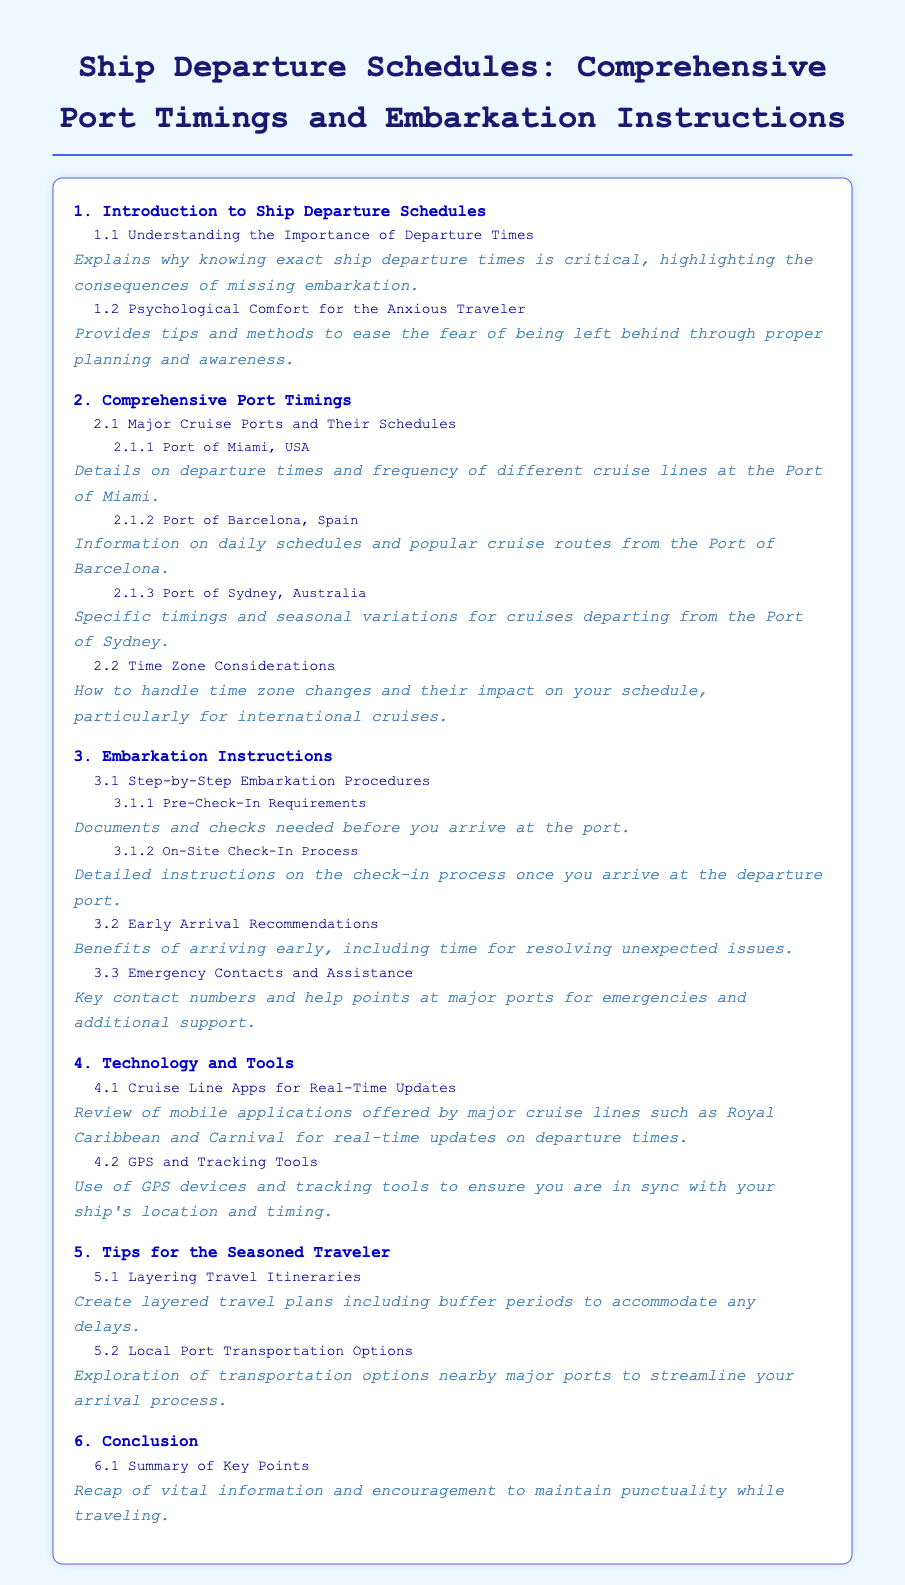what section discusses the importance of departure times? The section titled "Understanding the Importance of Departure Times" specifically explains the significance of knowing exact ship departure times.
Answer: Understanding the Importance of Departure Times which port has specific timings and seasonal variations mentioned? The section "Port of Sydney, Australia" details specific timings and seasonal variations for cruises.
Answer: Port of Sydney, Australia what are the recommendations for early arrival? The sub-item titled "Early Arrival Recommendations" outlines the benefits of arriving early at the port.
Answer: Early Arrival Recommendations how many major cruise ports are included in the document? The document lists three major cruise ports under "Comprehensive Port Timings."
Answer: Three what type of technology tools are mentioned for ensuring synchronization with the ship's location? The section "GPS and Tracking Tools" discusses the use of GPS devices and tracking tools.
Answer: GPS and Tracking Tools which cruise line app is noted for real-time updates? The document mentions mobile applications offered by major cruise lines like Royal Caribbean and Carnival for real-time updates.
Answer: Royal Caribbean and Carnival what key aspect is covered in the conclusion section? The "Summary of Key Points" in the conclusion recaps vital information related to maintaining punctuality.
Answer: Summary of Key Points what does the document state about handling time zone changes? The sub-item "Time Zone Considerations" addresses how to manage time zone changes during international cruises.
Answer: Time Zone Considerations 